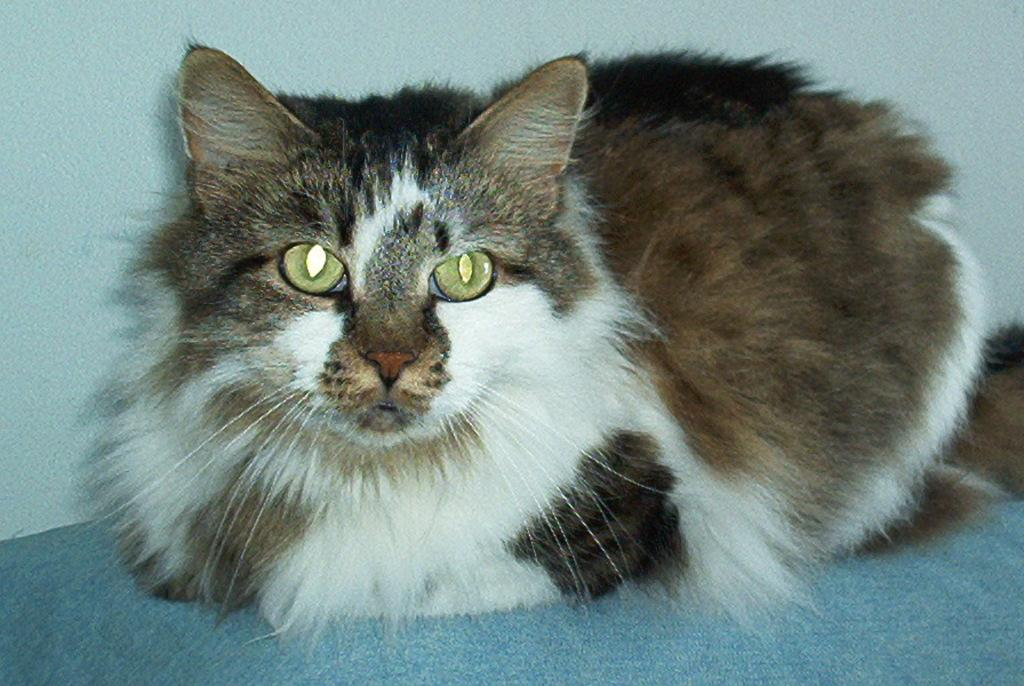What color is the object that the cat is on in the image? The object is blue. What type of animal is on the blue object in the image? There is a brown and white cat on the blue object. What can be seen in the background of the image? There is a wall visible in the background of the image. What does the stranger's voice sound like in the image? There is no stranger or voice present in the image. What type of hall can be seen in the image? There is no hall present in the image. 